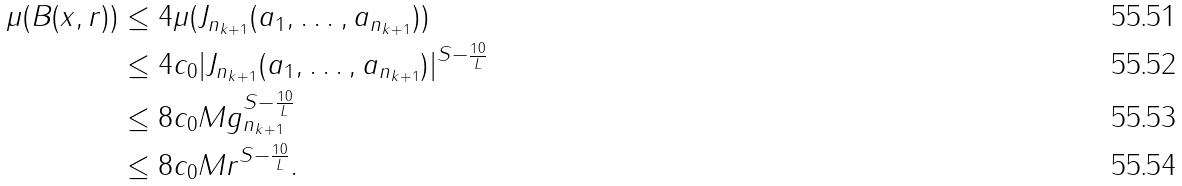<formula> <loc_0><loc_0><loc_500><loc_500>\mu ( B ( x , r ) ) & \leq 4 \mu ( J _ { n _ { k + 1 } } ( a _ { 1 } , \dots , a _ { n _ { k + 1 } } ) ) \\ & \leq 4 c _ { 0 } | J _ { n _ { k + 1 } } ( a _ { 1 } , \dots , a _ { n _ { k + 1 } } ) | ^ { S - \frac { 1 0 } { L } } \\ & \leq 8 c _ { 0 } M g _ { n _ { k + 1 } } ^ { S - \frac { 1 0 } { L } } \\ & \leq 8 c _ { 0 } M r ^ { S - \frac { 1 0 } { L } } .</formula> 